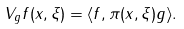<formula> <loc_0><loc_0><loc_500><loc_500>V _ { g } f ( x , \xi ) = \langle f , \pi ( x , \xi ) g \rangle .</formula> 